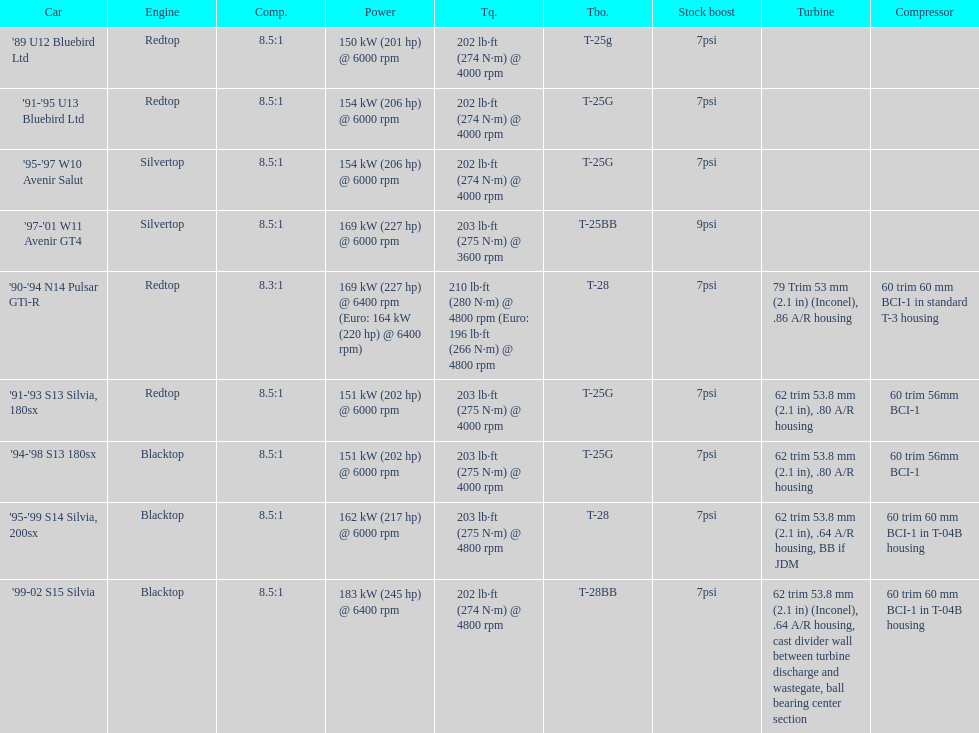Which cars featured blacktop engines? '94-'98 S13 180sx, '95-'99 S14 Silvia, 200sx, '99-02 S15 Silvia. Which of these had t-04b compressor housings? '95-'99 S14 Silvia, 200sx, '99-02 S15 Silvia. Which one of these has the highest horsepower? '99-02 S15 Silvia. 